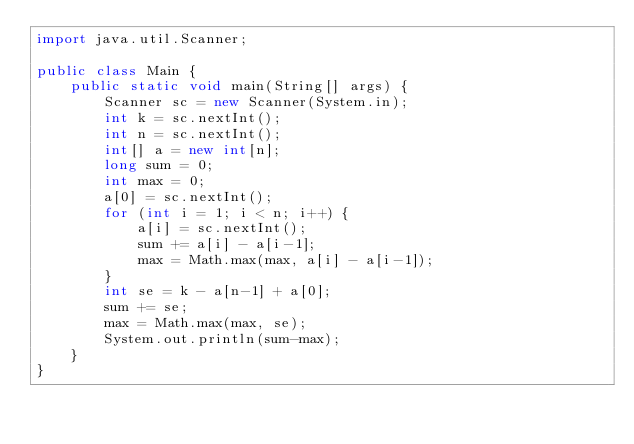Convert code to text. <code><loc_0><loc_0><loc_500><loc_500><_Java_>import java.util.Scanner;

public class Main {
    public static void main(String[] args) {
        Scanner sc = new Scanner(System.in);
        int k = sc.nextInt();
        int n = sc.nextInt();
        int[] a = new int[n];
        long sum = 0;
        int max = 0;
        a[0] = sc.nextInt();
        for (int i = 1; i < n; i++) {
            a[i] = sc.nextInt();
            sum += a[i] - a[i-1];
            max = Math.max(max, a[i] - a[i-1]);
        }
        int se = k - a[n-1] + a[0];
        sum += se;
        max = Math.max(max, se);
        System.out.println(sum-max);
    }
}</code> 